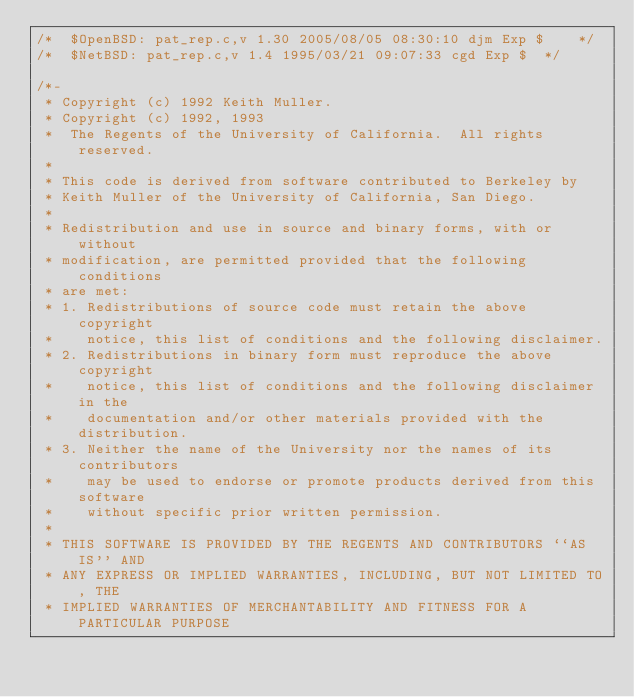Convert code to text. <code><loc_0><loc_0><loc_500><loc_500><_C_>/*	$OpenBSD: pat_rep.c,v 1.30 2005/08/05 08:30:10 djm Exp $	*/
/*	$NetBSD: pat_rep.c,v 1.4 1995/03/21 09:07:33 cgd Exp $	*/

/*-
 * Copyright (c) 1992 Keith Muller.
 * Copyright (c) 1992, 1993
 *	The Regents of the University of California.  All rights reserved.
 *
 * This code is derived from software contributed to Berkeley by
 * Keith Muller of the University of California, San Diego.
 *
 * Redistribution and use in source and binary forms, with or without
 * modification, are permitted provided that the following conditions
 * are met:
 * 1. Redistributions of source code must retain the above copyright
 *    notice, this list of conditions and the following disclaimer.
 * 2. Redistributions in binary form must reproduce the above copyright
 *    notice, this list of conditions and the following disclaimer in the
 *    documentation and/or other materials provided with the distribution.
 * 3. Neither the name of the University nor the names of its contributors
 *    may be used to endorse or promote products derived from this software
 *    without specific prior written permission.
 *
 * THIS SOFTWARE IS PROVIDED BY THE REGENTS AND CONTRIBUTORS ``AS IS'' AND
 * ANY EXPRESS OR IMPLIED WARRANTIES, INCLUDING, BUT NOT LIMITED TO, THE
 * IMPLIED WARRANTIES OF MERCHANTABILITY AND FITNESS FOR A PARTICULAR PURPOSE</code> 